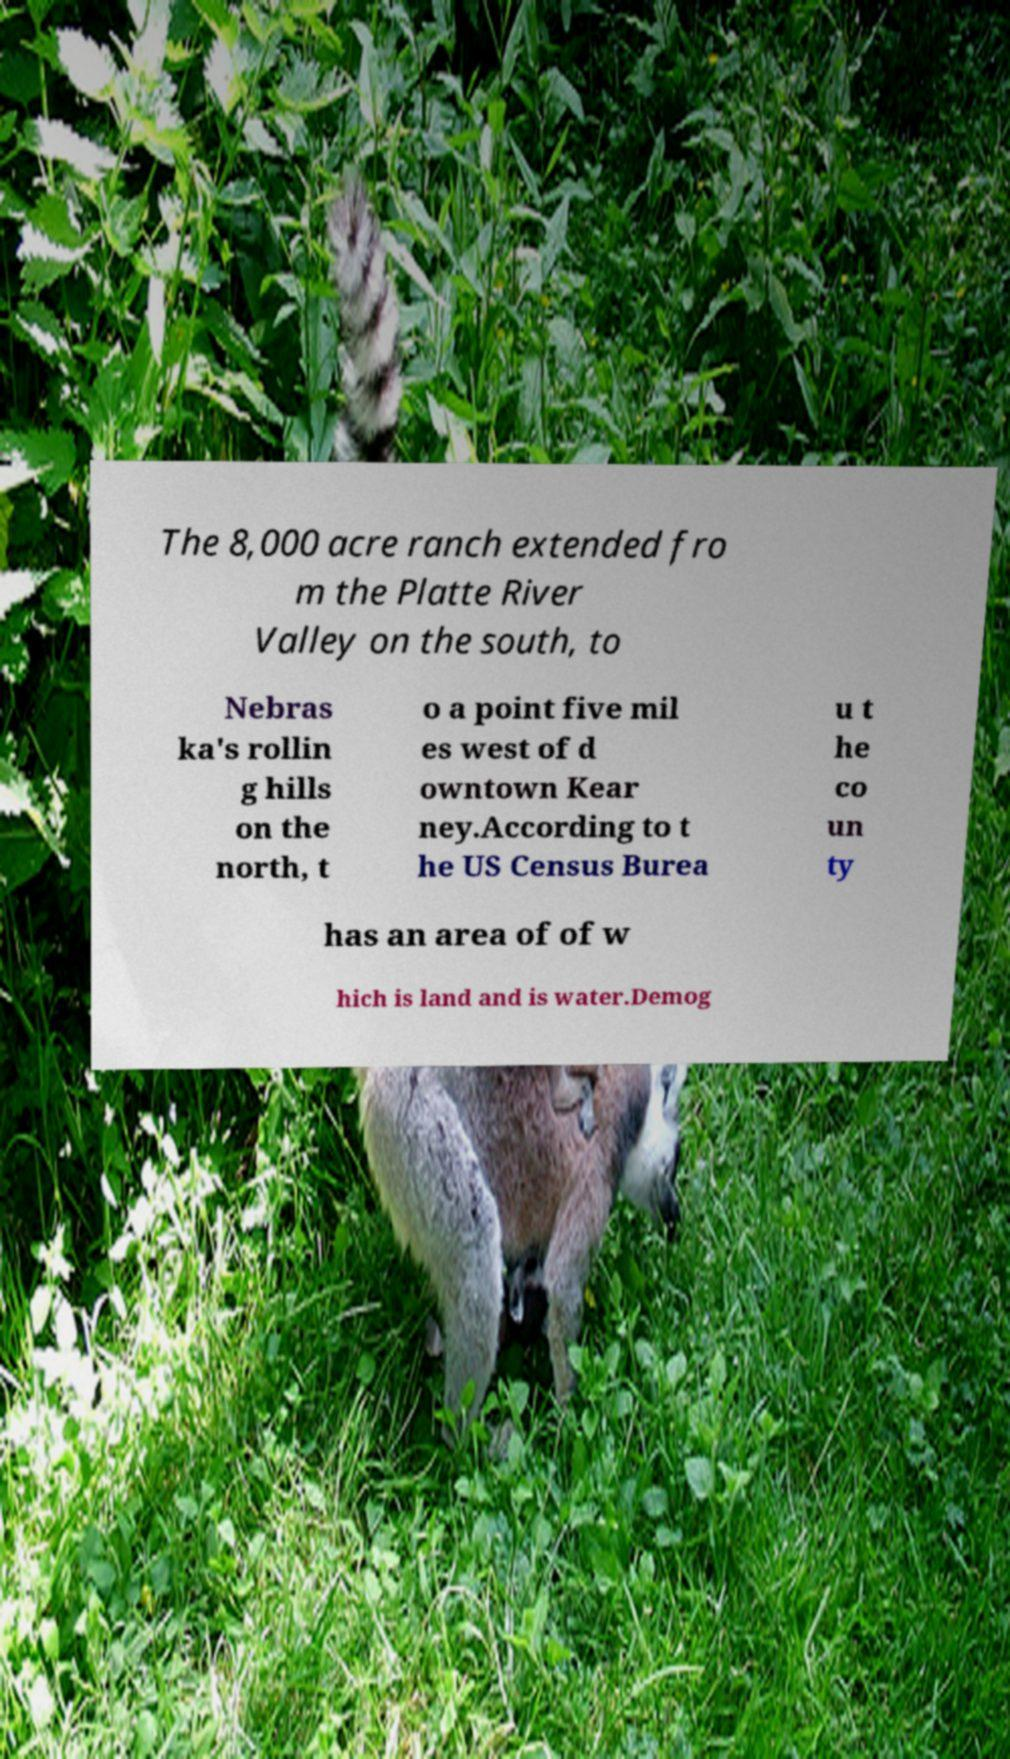Please identify and transcribe the text found in this image. The 8,000 acre ranch extended fro m the Platte River Valley on the south, to Nebras ka's rollin g hills on the north, t o a point five mil es west of d owntown Kear ney.According to t he US Census Burea u t he co un ty has an area of of w hich is land and is water.Demog 